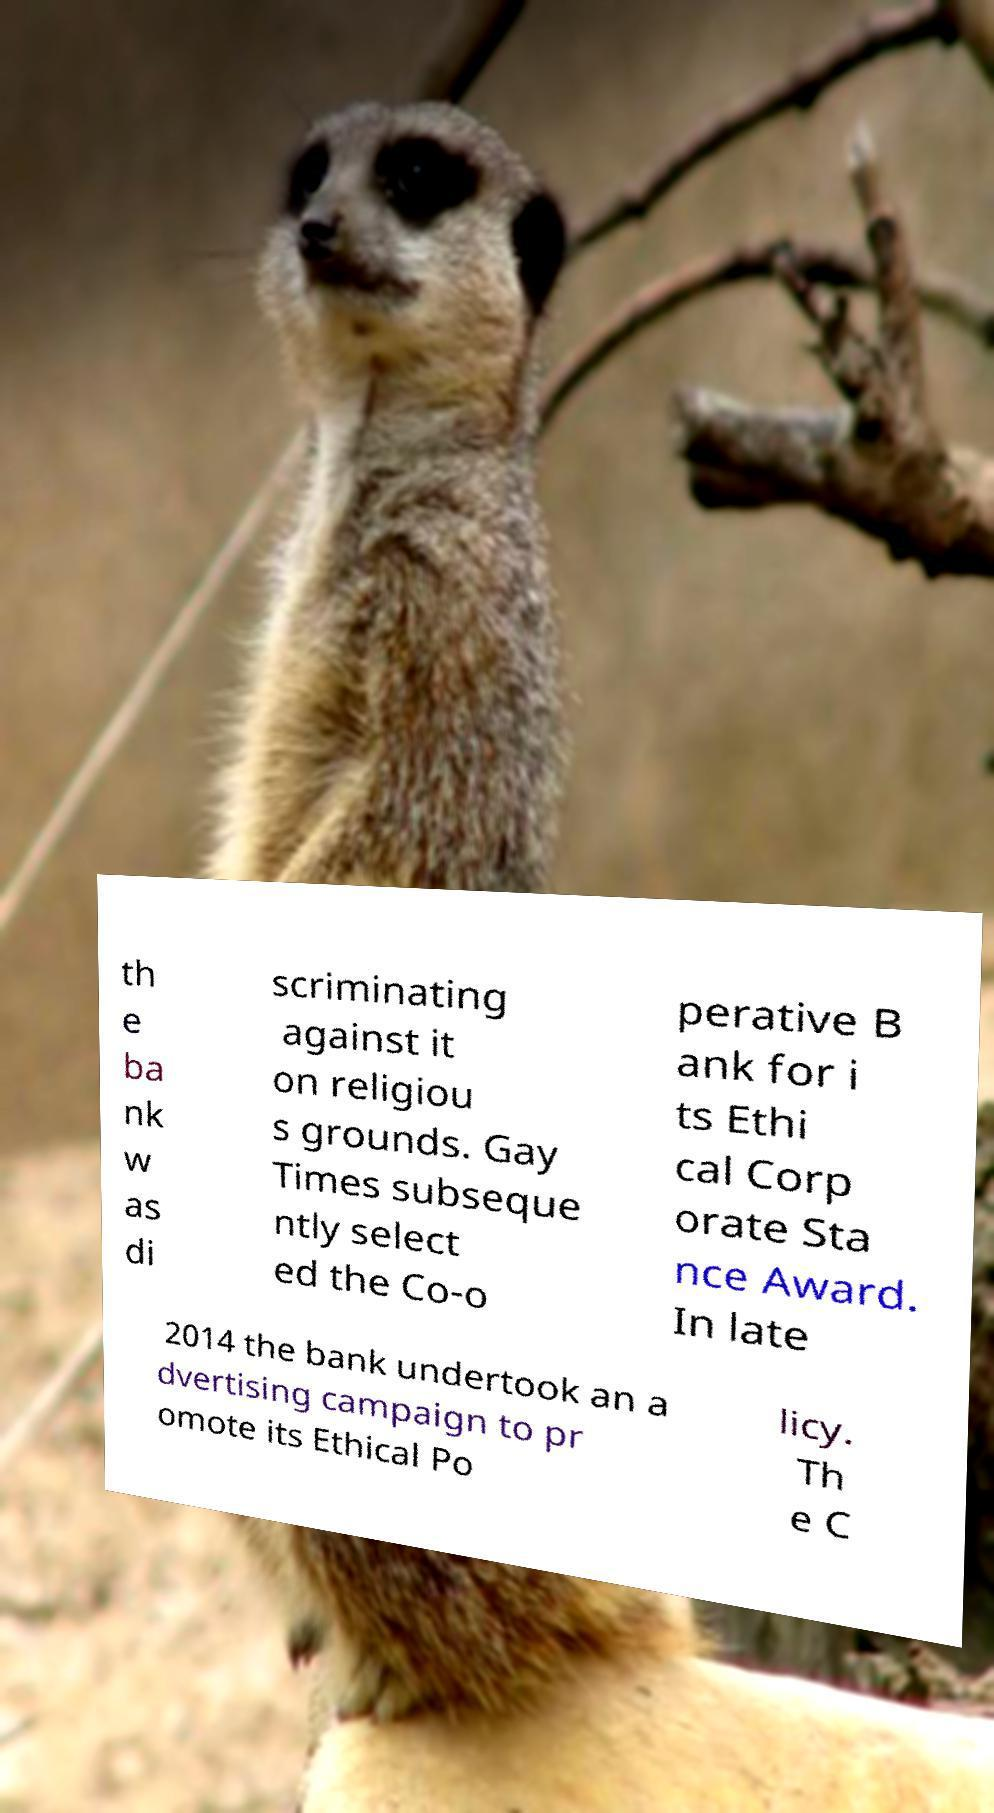Could you assist in decoding the text presented in this image and type it out clearly? th e ba nk w as di scriminating against it on religiou s grounds. Gay Times subseque ntly select ed the Co-o perative B ank for i ts Ethi cal Corp orate Sta nce Award. In late 2014 the bank undertook an a dvertising campaign to pr omote its Ethical Po licy. Th e C 